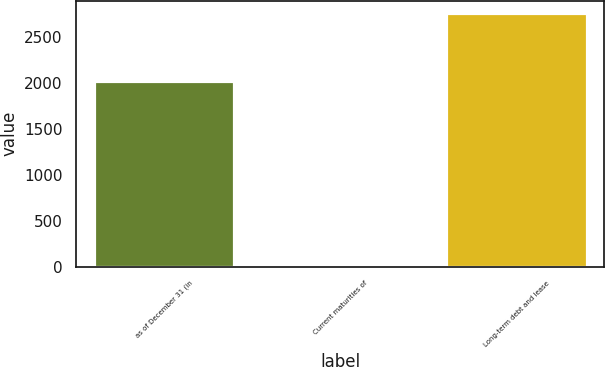<chart> <loc_0><loc_0><loc_500><loc_500><bar_chart><fcel>as of December 31 (in<fcel>Current maturities of<fcel>Long-term debt and lease<nl><fcel>2016<fcel>3<fcel>2756<nl></chart> 